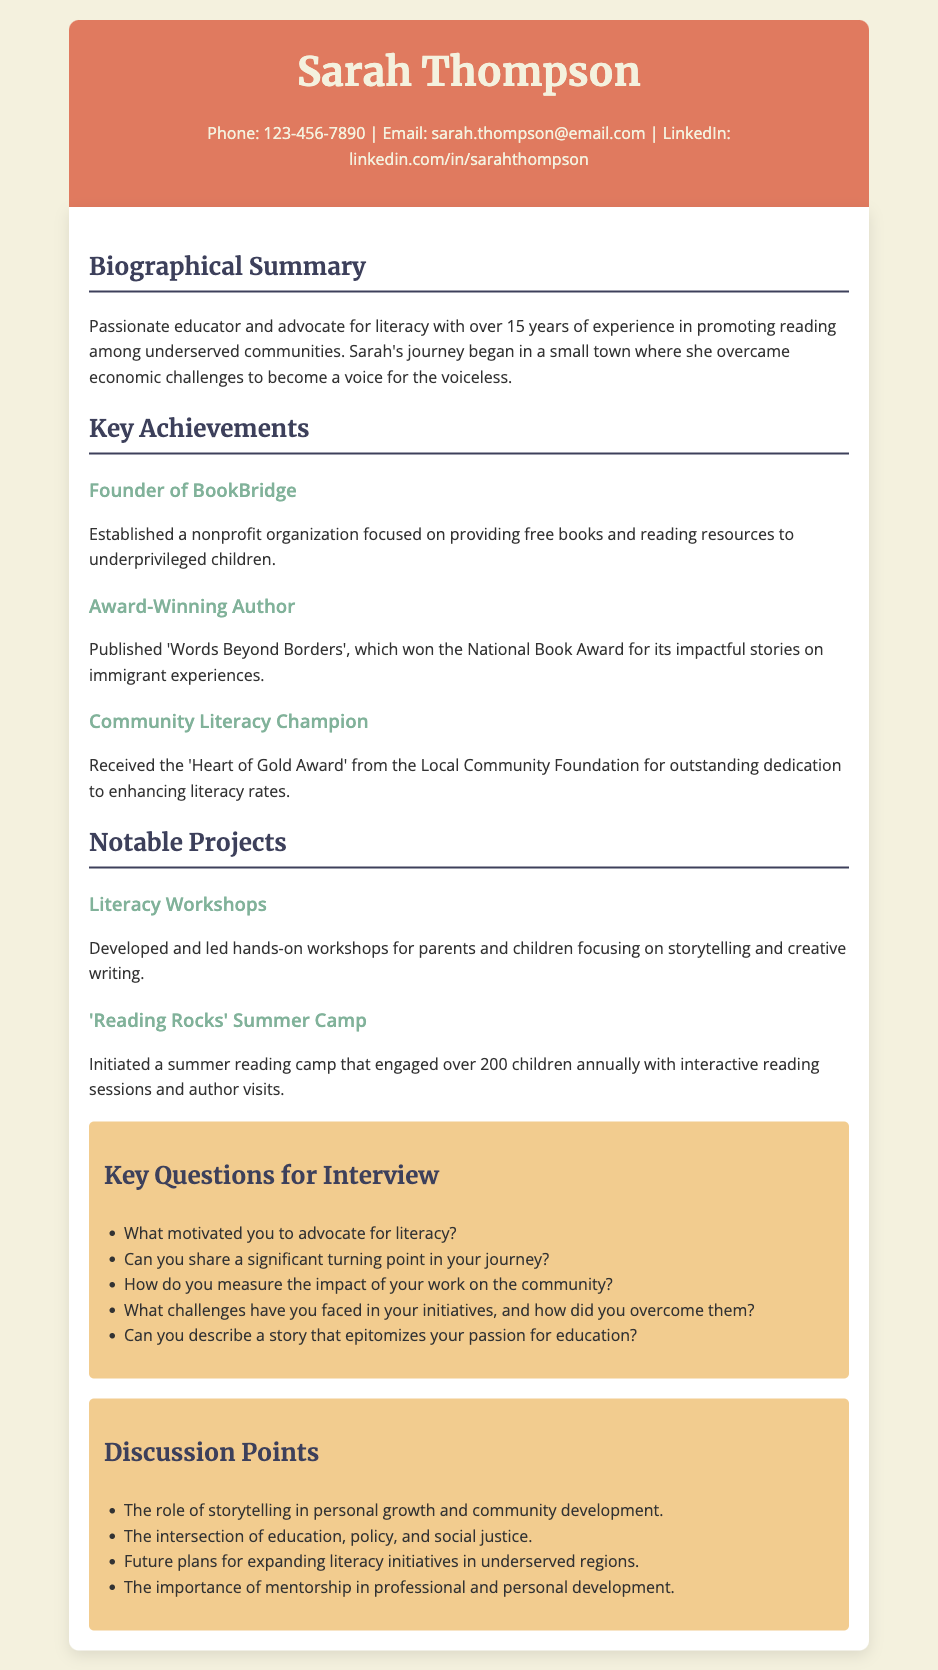What is Sarah Thompson's profession? The document states that Sarah is a passionate educator and advocate for literacy.
Answer: educator How many years of experience does Sarah have? The document mentions that Sarah has over 15 years of experience.
Answer: 15 years What is the name of the nonprofit organization Sarah founded? The achievements section lists 'BookBridge' as the name of the nonprofit organization.
Answer: BookBridge What award did Sarah's book 'Words Beyond Borders' win? The document states that the book won the National Book Award.
Answer: National Book Award What is a notable project initiated by Sarah during the summer? The document describes the 'Reading Rocks' Summer Camp as a notable project.
Answer: 'Reading Rocks' Summer Camp What is one key question to ask Sarah about her journey? One of the key questions listed is about the motivation behind her advocacy for literacy.
Answer: What motivated you to advocate for literacy? Which award did Sarah receive from the Local Community Foundation? The document indicates she received the 'Heart of Gold Award'.
Answer: Heart of Gold Award What is a significant topic for discussion mentioned in the document? The document lists the intersection of education, policy, and social justice as a discussion point.
Answer: education, policy, and social justice What type of workshops did Sarah develop? The document notes that she developed literacy workshops for parents and children.
Answer: literacy workshops What year range does Sarah's experience span? The document states her experience is over 15 years, but does not specify exact years.
Answer: over 15 years 